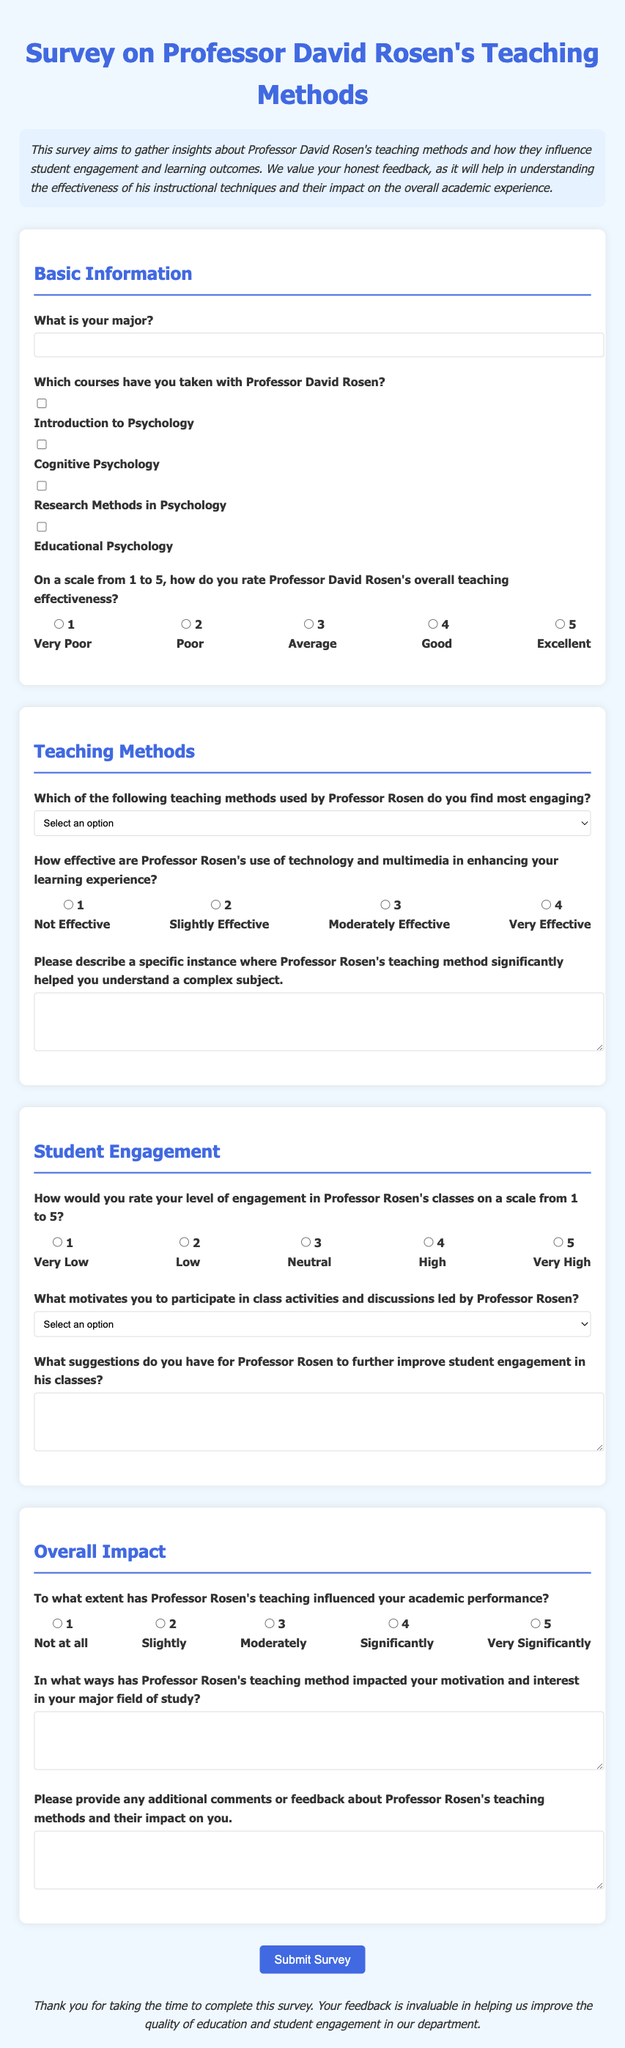What is the title of the survey? The title is found at the top of the document and indicates the focus of the survey on teaching methods.
Answer: Survey on Professor David Rosen's Teaching Methods What is the purpose of the survey? The purpose is outlined in the description section of the document, highlighting the aim to gather insights about teaching methods and their impact.
Answer: To gather insights about Professor David Rosen's teaching methods and how they influence student engagement and learning outcomes How many courses can students select that they have taken with Professor Rosen? The document provides a list of courses with checkboxes that can be selected by the respondents.
Answer: Four courses On a scale from 1 to 5, how would you rate Professor Rosen's overall teaching effectiveness? This question requires the respondent to choose a number between 1 and 5 to express their opinion on his teaching effectiveness.
Answer: 1 to 5 Which teaching method does the survey ask about as the most engaging? This question can be answered based on the options given in the teaching methods section of the survey.
Answer: Lectures with Interactive Discussions What motivates students to participate in class activities and discussions led by Professor Rosen? This is a question that allows students to choose from multiple options regarding their motivation for engagement.
Answer: Interest in the Subject In which section can you find a question about the effectiveness of technology and multimedia? This question requires knowledge of the structure of the document and where specific inquiries are placed.
Answer: Teaching Methods What is the last section of the survey called? The document has organized sections and indicates the final area for feedback.
Answer: Overall Impact What is the background color of the survey page? This refers to the visual design choices made within the document's styling.
Answer: #f0f8ff 